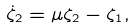<formula> <loc_0><loc_0><loc_500><loc_500>\dot { \zeta } _ { 2 } = \mu \zeta _ { 2 } - \zeta _ { 1 } ,</formula> 